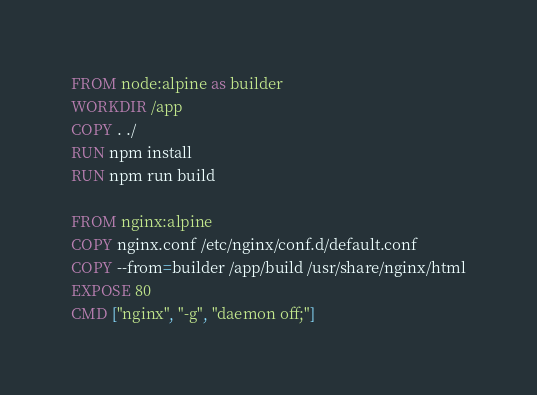<code> <loc_0><loc_0><loc_500><loc_500><_Dockerfile_>FROM node:alpine as builder
WORKDIR /app
COPY . ./
RUN npm install
RUN npm run build

FROM nginx:alpine
COPY nginx.conf /etc/nginx/conf.d/default.conf
COPY --from=builder /app/build /usr/share/nginx/html
EXPOSE 80
CMD ["nginx", "-g", "daemon off;"]
</code> 